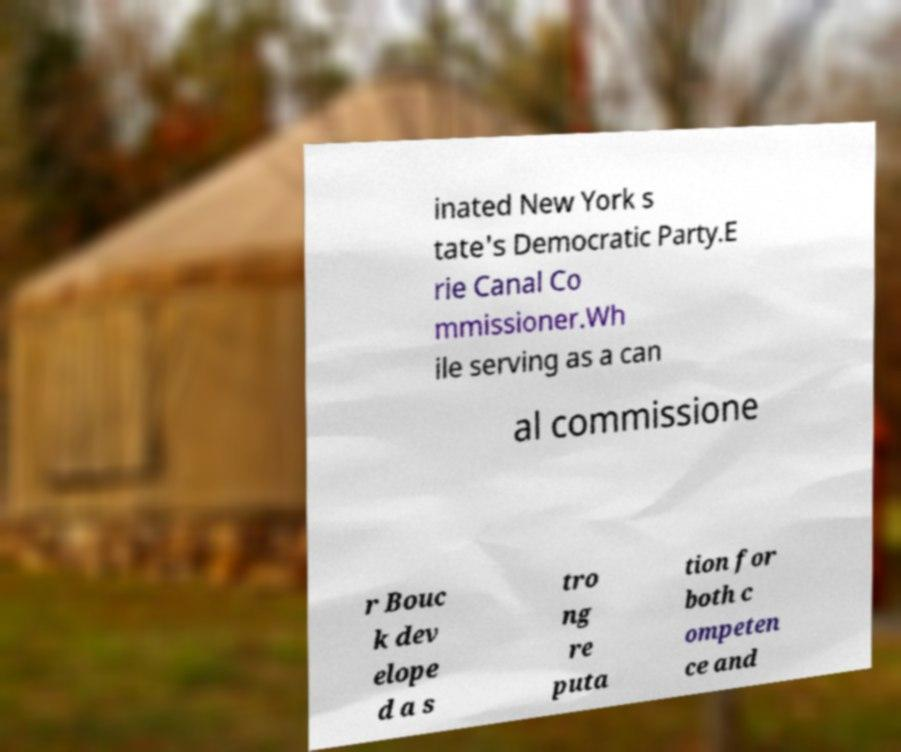For documentation purposes, I need the text within this image transcribed. Could you provide that? inated New York s tate's Democratic Party.E rie Canal Co mmissioner.Wh ile serving as a can al commissione r Bouc k dev elope d a s tro ng re puta tion for both c ompeten ce and 